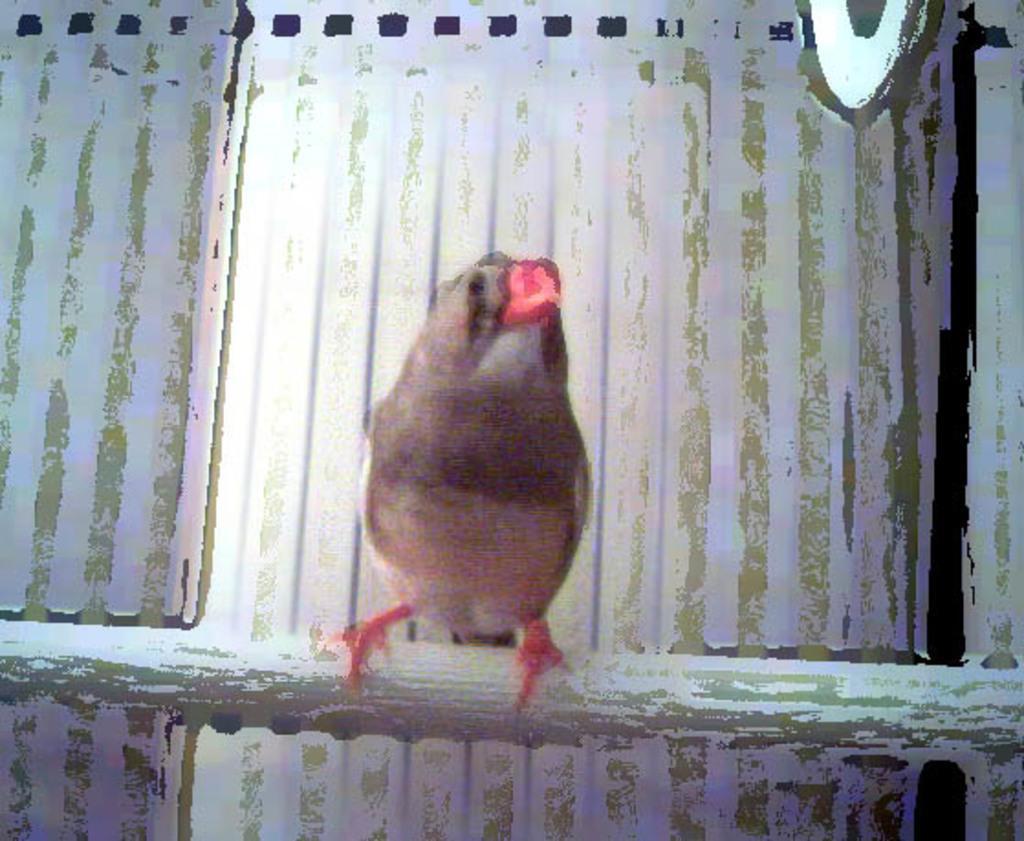Can you describe this image briefly? In the middle of this image there is a bird. In the background I can see white color paint. 